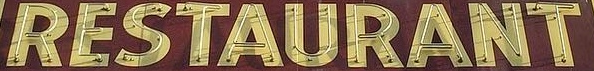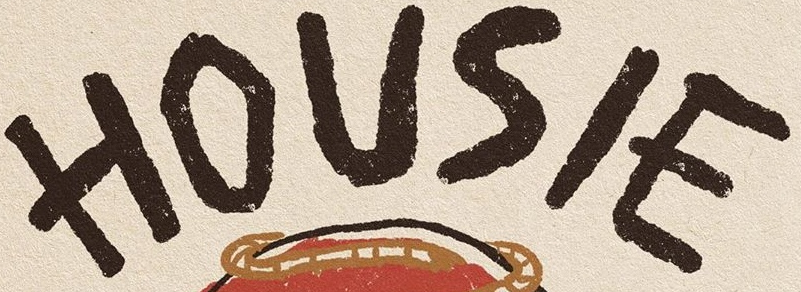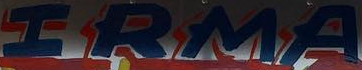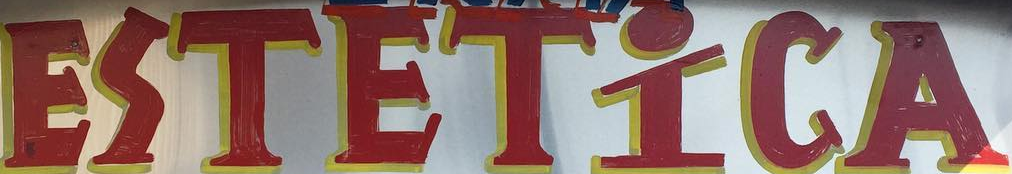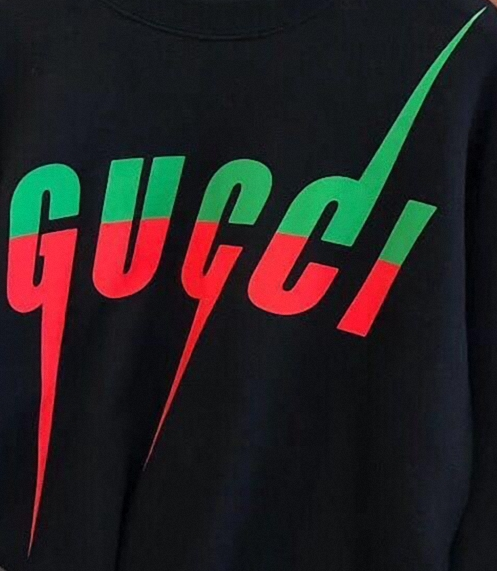Read the text from these images in sequence, separated by a semicolon. RESTAURANT; HOUSIE; IRMA; ESTETİCA; GUCCI 